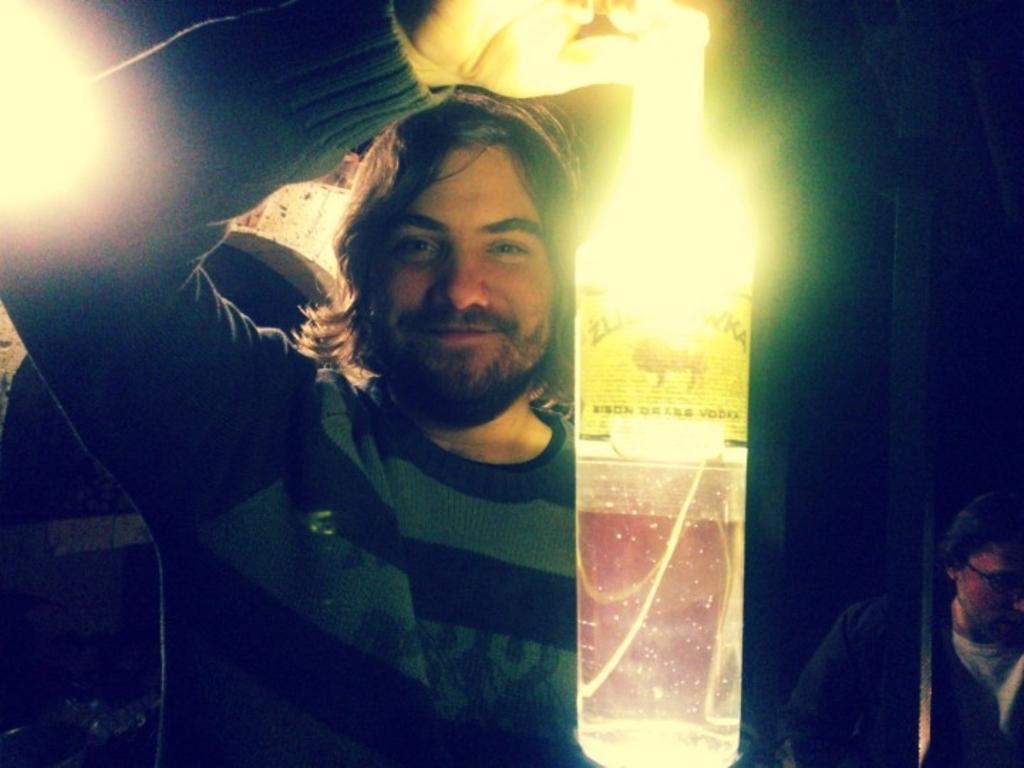Could you give a brief overview of what you see in this image? In this image I can see two people with different color dresses. I can see one person is holding the bottle. I can also see some lights. And there is a black background. 